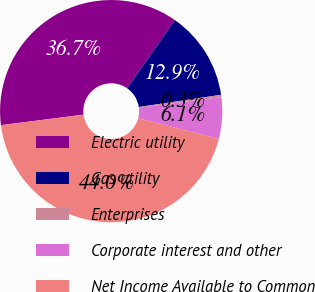Convert chart. <chart><loc_0><loc_0><loc_500><loc_500><pie_chart><fcel>Electric utility<fcel>Gas utility<fcel>Enterprises<fcel>Corporate interest and other<fcel>Net Income Available to Common<nl><fcel>36.72%<fcel>12.94%<fcel>0.34%<fcel>6.05%<fcel>43.95%<nl></chart> 